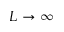<formula> <loc_0><loc_0><loc_500><loc_500>L \rightarrow \infty</formula> 